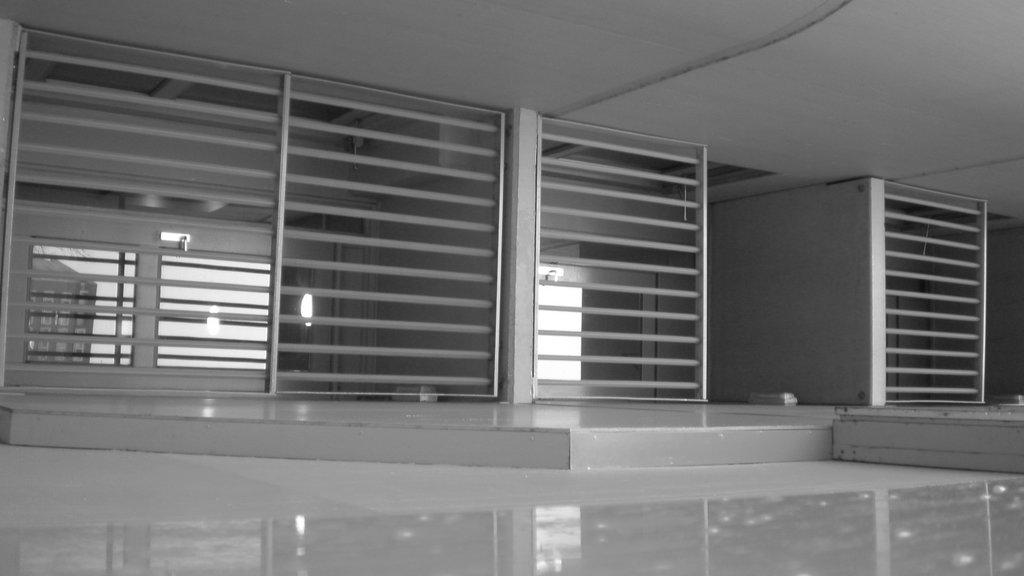What type of structure can be seen in the image? There is a wall in the image. What can be used for illumination in the image? There is a light in the image. What type of architectural feature is present in the image? There are window grilles in the image. What is the surface beneath the objects in the image? There is a floor in the image. What is the surface above the objects in the image? There is a ceiling in the image. What type of dress is the ladybug wearing in the image? There is no ladybug present in the image, and therefore no dress can be observed. Who is the expert in the image? There is no expert present in the image. 